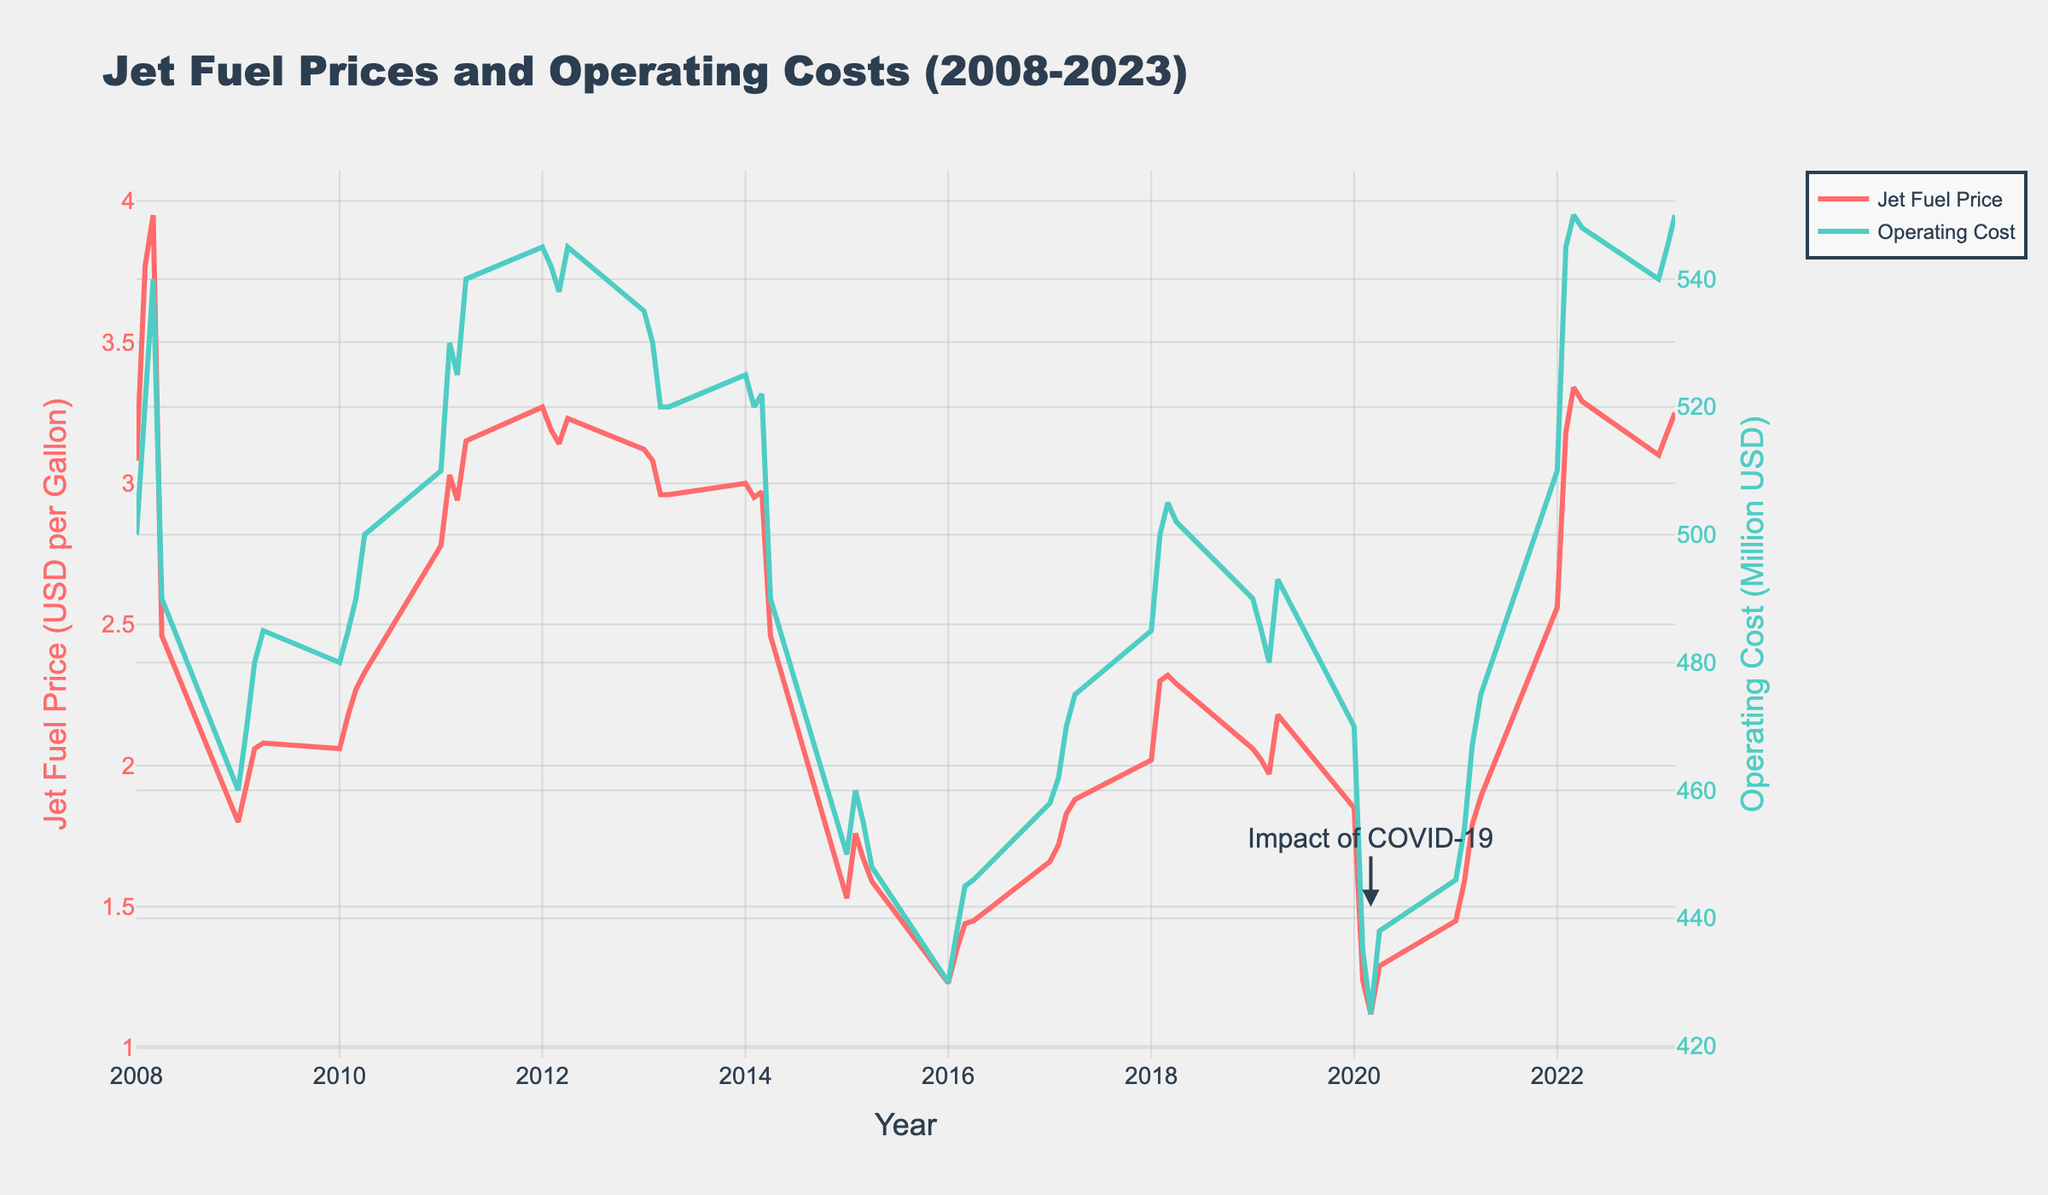What is the title of the plot? The title is positioned at the top of the plot and describes the main focus of the figure.
Answer: Jet Fuel Prices and Operating Costs (2008-2023) What does the x-axis represent in the plot? The x-axis, labeled "Year," represents the timeline over which the data is plotted.
Answer: Year What are the units for Jet Fuel Price on the y-axis? The left y-axis is labeled "Jet Fuel Price (USD per Gallon)," indicating the units for the price data.
Answer: USD per Gallon When did the Jet Fuel Price reach its lowest point, and what was the price? Locate the lowest point on the Jet Fuel Price line and note the corresponding date and price.
Answer: Q1 2016, 1.23 USD per Gallon What trend is observed in Operating Costs around Q2 2020, and how might this relate to external events? Observe the sharp drop in Operating Costs around Q2 2020, which coincides with the COVID-19 impact annotation. The pandemic likely caused reduced travel and, consequently, lower operating costs.
Answer: A significant drop due to COVID-19 How did Jet Fuel Prices change between Q1 2008 and Q1 2009? Note the Jet Fuel Price in Q1 2008 and Q1 2009, then calculate the change by subtraction. The prices are 3.08 and 1.80 respectively. 3.08 - 1.80 = 1.28
Answer: Decreased by 1.28 USD per Gallon Compare the Operating Costs in Q1 2015 and Q1 2019. Which was higher and by how much? Find the Operating Costs for Q1 2015 and Q1 2019 from the right y-axis. The costs are 450 million USD in 2015 and 490 million USD in 2019. Calculate the difference: 490 - 450 = 40
Answer: Q1 2019, by 40 million USD During what period did the Jet Fuel Price see a sharp increase, and how did the Operating Costs respond? Identify a period of sharp Jet Fuel Price increase and observe the corresponding changes in Operating Costs. An example is between Q1 2022 and Q3 2022. Jet Fuel Price increases from 2.56 to 3.34 USD per Gallon, leading to an increase in Operating Costs from 510 to 550 million USD.
Answer: Q1 2022 to Q3 2022; Operating Costs also increased What is the relationship between Jet Fuel Prices and Operating Costs from 2008-2023? By examining the trends closely, we can see that as Jet Fuel Prices generally increase or decrease, Operating Costs show a similar pattern. This indicates a direct relationship.
Answer: Direct/positive relationship What can you infer about the impact of fuel price changes on Operating Costs over the entire period? Analyze the general trends and fluctuations in both time series to infer a strong correlation where increasing fuel prices lead to higher Operating Costs and vice versa.
Answer: Higher fuel prices generally increase Operating Costs What was the range of Jet Fuel Prices observed in the plot? Identify the highest and lowest points on the Jet Fuel Price line to determine the range. The highest is around 3.95 USD per Gallon (Q3 2008) and the lowest is around 1.23 USD per Gallon (Q1 2016). The range is 3.95 - 1.23 = 2.72 USD per Gallon.
Answer: 2.72 USD per Gallon 